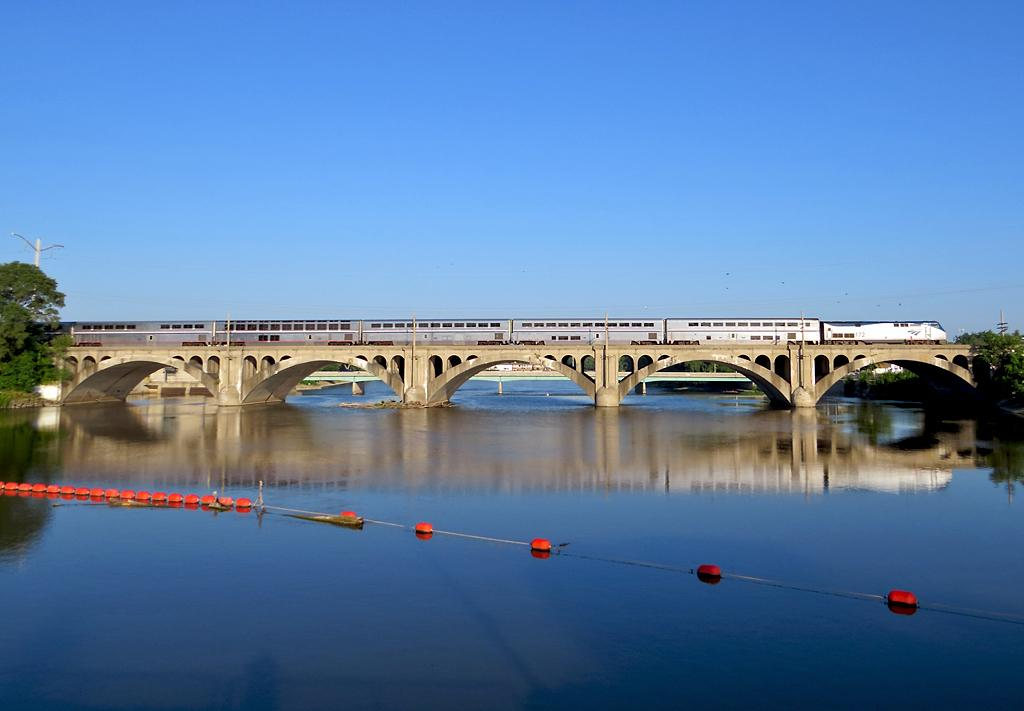What color are the objects that are connected by a rope in the image? The objects are red in color. How are the red objects connected in the image? The red objects are connected by a rope. Where are the red objects located in relation to the water? The red objects are above the water. What can be seen in the background of the image? In the background of the image, there is a train on a bridge, trees, poles, and a blue sky. What type of dock can be seen in the image? There is no dock present in the image. What trade agreement is being discussed in the image? There is no discussion of trade agreements in the image. 